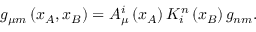<formula> <loc_0><loc_0><loc_500><loc_500>g _ { \mu m } \left ( x _ { A } , x _ { B } \right ) = A _ { \mu } ^ { i } \left ( x _ { A } \right ) K _ { i } ^ { n } \left ( x _ { B } \right ) g _ { n m } .</formula> 